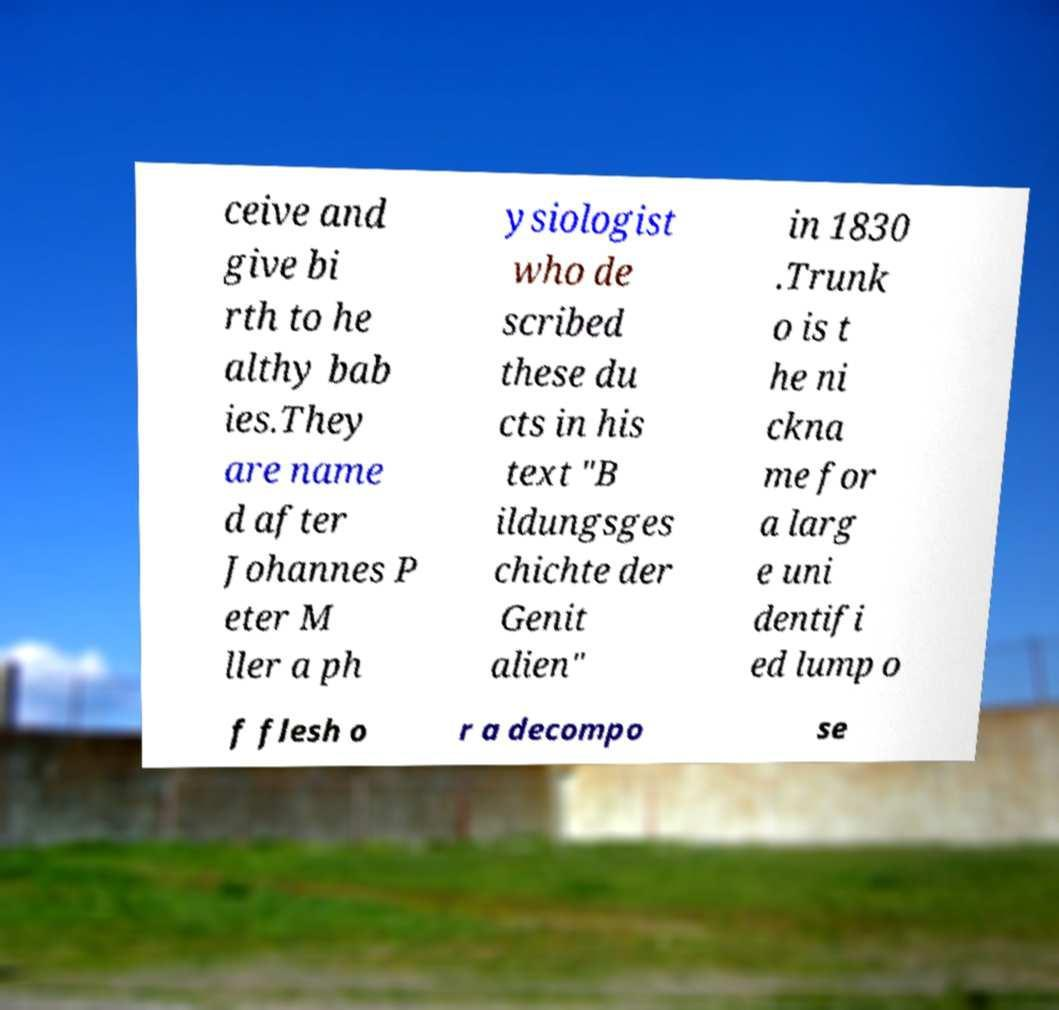Can you read and provide the text displayed in the image?This photo seems to have some interesting text. Can you extract and type it out for me? ceive and give bi rth to he althy bab ies.They are name d after Johannes P eter M ller a ph ysiologist who de scribed these du cts in his text "B ildungsges chichte der Genit alien" in 1830 .Trunk o is t he ni ckna me for a larg e uni dentifi ed lump o f flesh o r a decompo se 